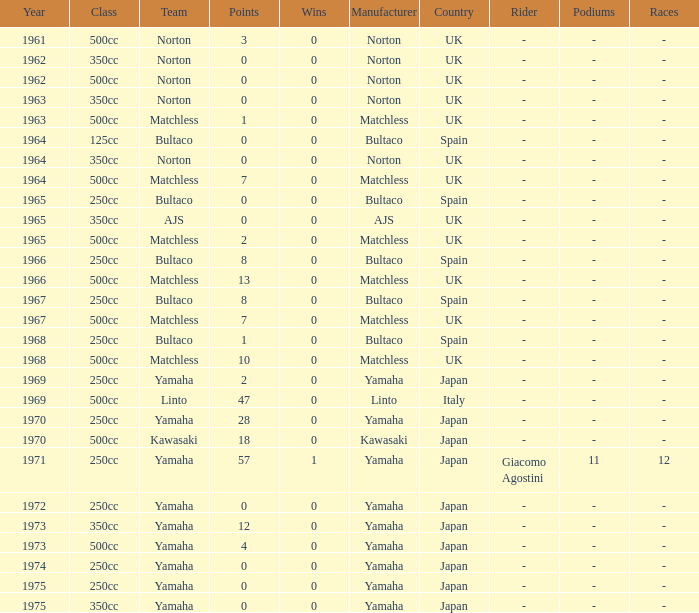Which class corresponds to more than 2 points, wins greater than 0, and a year earlier than 1973? 250cc. 